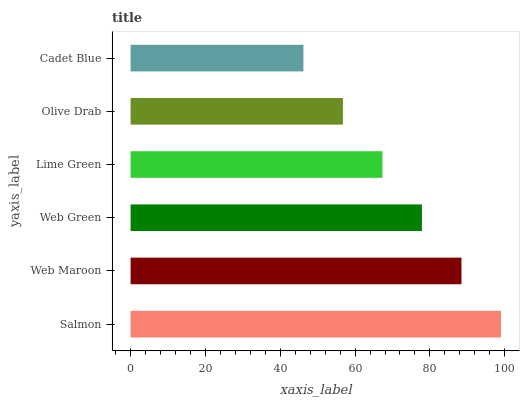Is Cadet Blue the minimum?
Answer yes or no. Yes. Is Salmon the maximum?
Answer yes or no. Yes. Is Web Maroon the minimum?
Answer yes or no. No. Is Web Maroon the maximum?
Answer yes or no. No. Is Salmon greater than Web Maroon?
Answer yes or no. Yes. Is Web Maroon less than Salmon?
Answer yes or no. Yes. Is Web Maroon greater than Salmon?
Answer yes or no. No. Is Salmon less than Web Maroon?
Answer yes or no. No. Is Web Green the high median?
Answer yes or no. Yes. Is Lime Green the low median?
Answer yes or no. Yes. Is Lime Green the high median?
Answer yes or no. No. Is Olive Drab the low median?
Answer yes or no. No. 